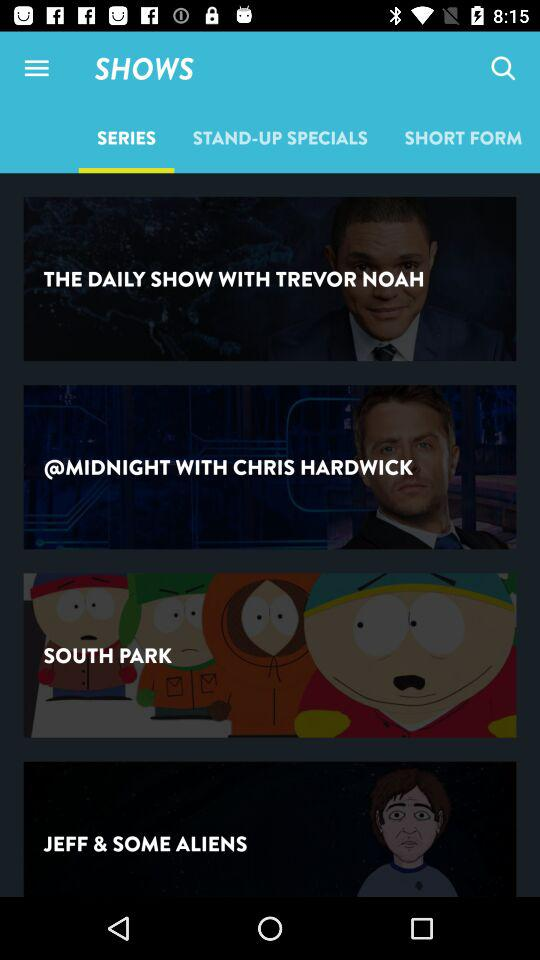Which tab is selected? The selected tab is "SERIES". 